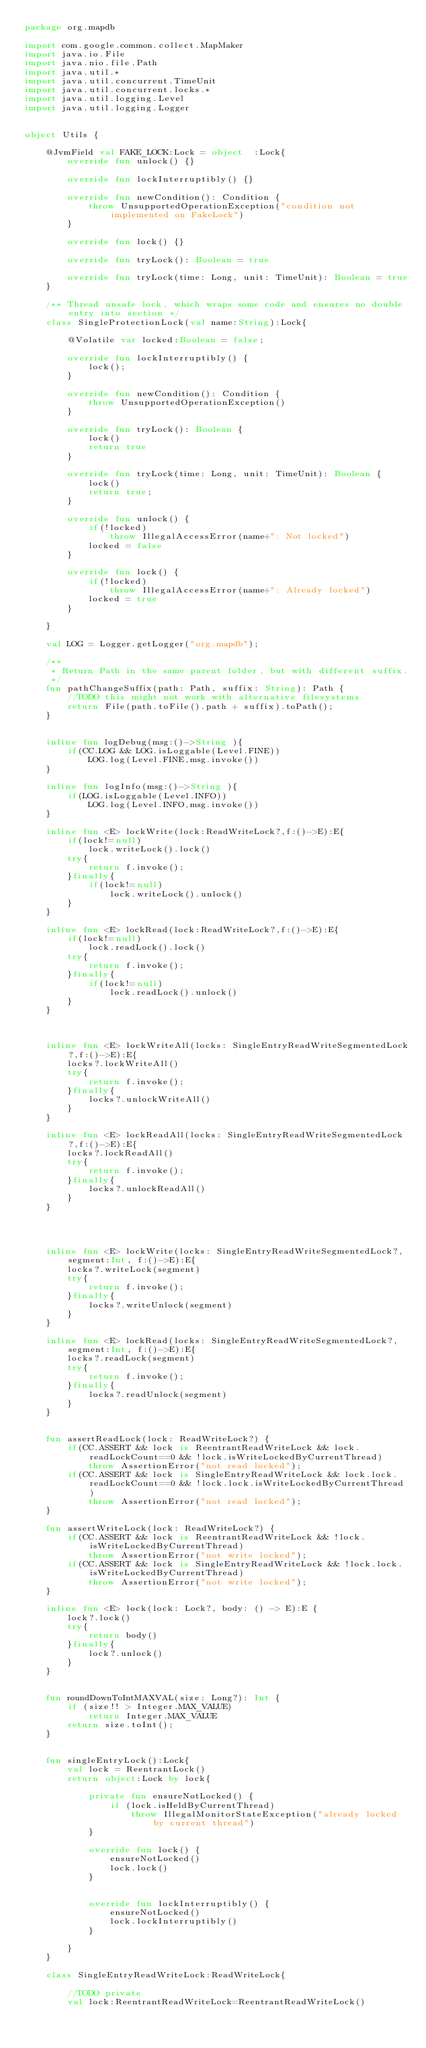Convert code to text. <code><loc_0><loc_0><loc_500><loc_500><_Kotlin_>package org.mapdb

import com.google.common.collect.MapMaker
import java.io.File
import java.nio.file.Path
import java.util.*
import java.util.concurrent.TimeUnit
import java.util.concurrent.locks.*
import java.util.logging.Level
import java.util.logging.Logger


object Utils {

    @JvmField val FAKE_LOCK:Lock = object  :Lock{
        override fun unlock() {}

        override fun lockInterruptibly() {}

        override fun newCondition(): Condition {
            throw UnsupportedOperationException("condition not implemented on FakeLock")
        }

        override fun lock() {}

        override fun tryLock(): Boolean = true

        override fun tryLock(time: Long, unit: TimeUnit): Boolean = true
    }

    /** Thread unsafe lock, which wraps some code and ensures no double entry into section */
    class SingleProtectionLock(val name:String):Lock{

        @Volatile var locked:Boolean = false;

        override fun lockInterruptibly() {
            lock();
        }

        override fun newCondition(): Condition {
            throw UnsupportedOperationException()
        }

        override fun tryLock(): Boolean {
            lock()
            return true
        }

        override fun tryLock(time: Long, unit: TimeUnit): Boolean {
            lock()
            return true;
        }

        override fun unlock() {
            if(!locked)
                throw IllegalAccessError(name+": Not locked")
            locked = false
        }

        override fun lock() {
            if(!locked)
                throw IllegalAccessError(name+": Already locked")
            locked = true
        }

    }

    val LOG = Logger.getLogger("org.mapdb");

    /**
     * Return Path in the same parent folder, but with different suffix.
     */
    fun pathChangeSuffix(path: Path, suffix: String): Path {
        //TODO this might not work with alternative filesystems
        return File(path.toFile().path + suffix).toPath();
    }


    inline fun logDebug(msg:()->String ){
        if(CC.LOG && LOG.isLoggable(Level.FINE))
            LOG.log(Level.FINE,msg.invoke())
    }

    inline fun logInfo(msg:()->String ){
        if(LOG.isLoggable(Level.INFO))
            LOG.log(Level.INFO,msg.invoke())
    }

    inline fun <E> lockWrite(lock:ReadWriteLock?,f:()->E):E{
        if(lock!=null)
            lock.writeLock().lock()
        try{
            return f.invoke();
        }finally{
            if(lock!=null)
                lock.writeLock().unlock()
        }
    }

    inline fun <E> lockRead(lock:ReadWriteLock?,f:()->E):E{
        if(lock!=null)
            lock.readLock().lock()
        try{
            return f.invoke();
        }finally{
            if(lock!=null)
                lock.readLock().unlock()
        }
    }



    inline fun <E> lockWriteAll(locks: SingleEntryReadWriteSegmentedLock?,f:()->E):E{
        locks?.lockWriteAll()
        try{
            return f.invoke();
        }finally{
            locks?.unlockWriteAll()
        }
    }

    inline fun <E> lockReadAll(locks: SingleEntryReadWriteSegmentedLock?,f:()->E):E{
        locks?.lockReadAll()
        try{
            return f.invoke();
        }finally{
            locks?.unlockReadAll()
        }
    }




    inline fun <E> lockWrite(locks: SingleEntryReadWriteSegmentedLock?, segment:Int, f:()->E):E{
        locks?.writeLock(segment)
        try{
            return f.invoke();
        }finally{
            locks?.writeUnlock(segment)
        }
    }

    inline fun <E> lockRead(locks: SingleEntryReadWriteSegmentedLock?, segment:Int, f:()->E):E{
        locks?.readLock(segment)
        try{
            return f.invoke();
        }finally{
            locks?.readUnlock(segment)
        }
    }


    fun assertReadLock(lock: ReadWriteLock?) {
        if(CC.ASSERT && lock is ReentrantReadWriteLock && lock.readLockCount==0 && !lock.isWriteLockedByCurrentThread)
            throw AssertionError("not read locked");
        if(CC.ASSERT && lock is SingleEntryReadWriteLock && lock.lock.readLockCount==0 && !lock.lock.isWriteLockedByCurrentThread)
            throw AssertionError("not read locked");
    }

    fun assertWriteLock(lock: ReadWriteLock?) {
        if(CC.ASSERT && lock is ReentrantReadWriteLock && !lock.isWriteLockedByCurrentThread)
            throw AssertionError("not write locked");
        if(CC.ASSERT && lock is SingleEntryReadWriteLock && !lock.lock.isWriteLockedByCurrentThread)
            throw AssertionError("not write locked");
    }

    inline fun <E> lock(lock: Lock?, body: () -> E):E {
        lock?.lock()
        try{
            return body()
        }finally{
            lock?.unlock()
        }
    }


    fun roundDownToIntMAXVAL(size: Long?): Int {
        if (size!! > Integer.MAX_VALUE)
            return Integer.MAX_VALUE
        return size.toInt();
    }


    fun singleEntryLock():Lock{
        val lock = ReentrantLock()
        return object:Lock by lock{

            private fun ensureNotLocked() {
                if (lock.isHeldByCurrentThread)
                    throw IllegalMonitorStateException("already locked by current thread")
            }

            override fun lock() {
                ensureNotLocked()
                lock.lock()
            }


            override fun lockInterruptibly() {
                ensureNotLocked()
                lock.lockInterruptibly()
            }

        }
    }

    class SingleEntryReadWriteLock:ReadWriteLock{

        //TODO private
        val lock:ReentrantReadWriteLock=ReentrantReadWriteLock()
</code> 